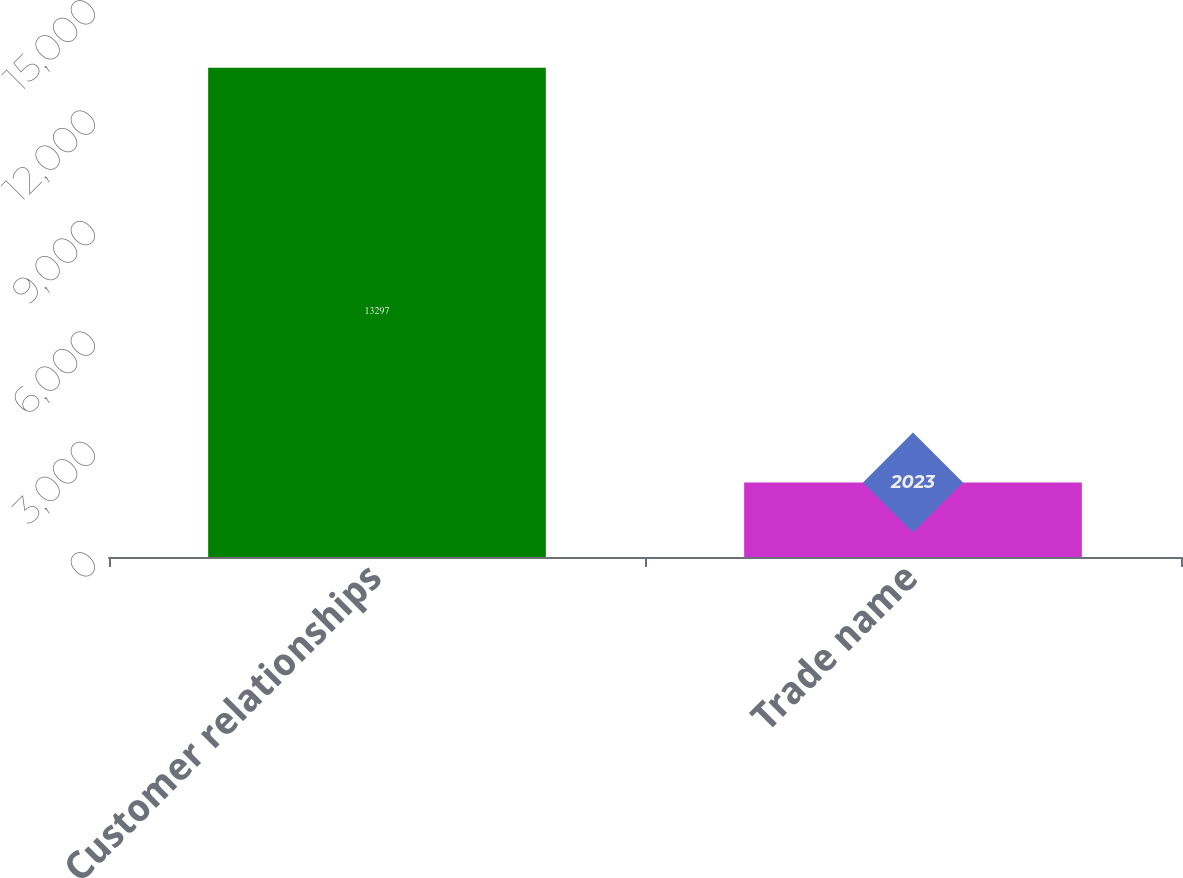Convert chart to OTSL. <chart><loc_0><loc_0><loc_500><loc_500><bar_chart><fcel>Customer relationships<fcel>Trade name<nl><fcel>13297<fcel>2023<nl></chart> 